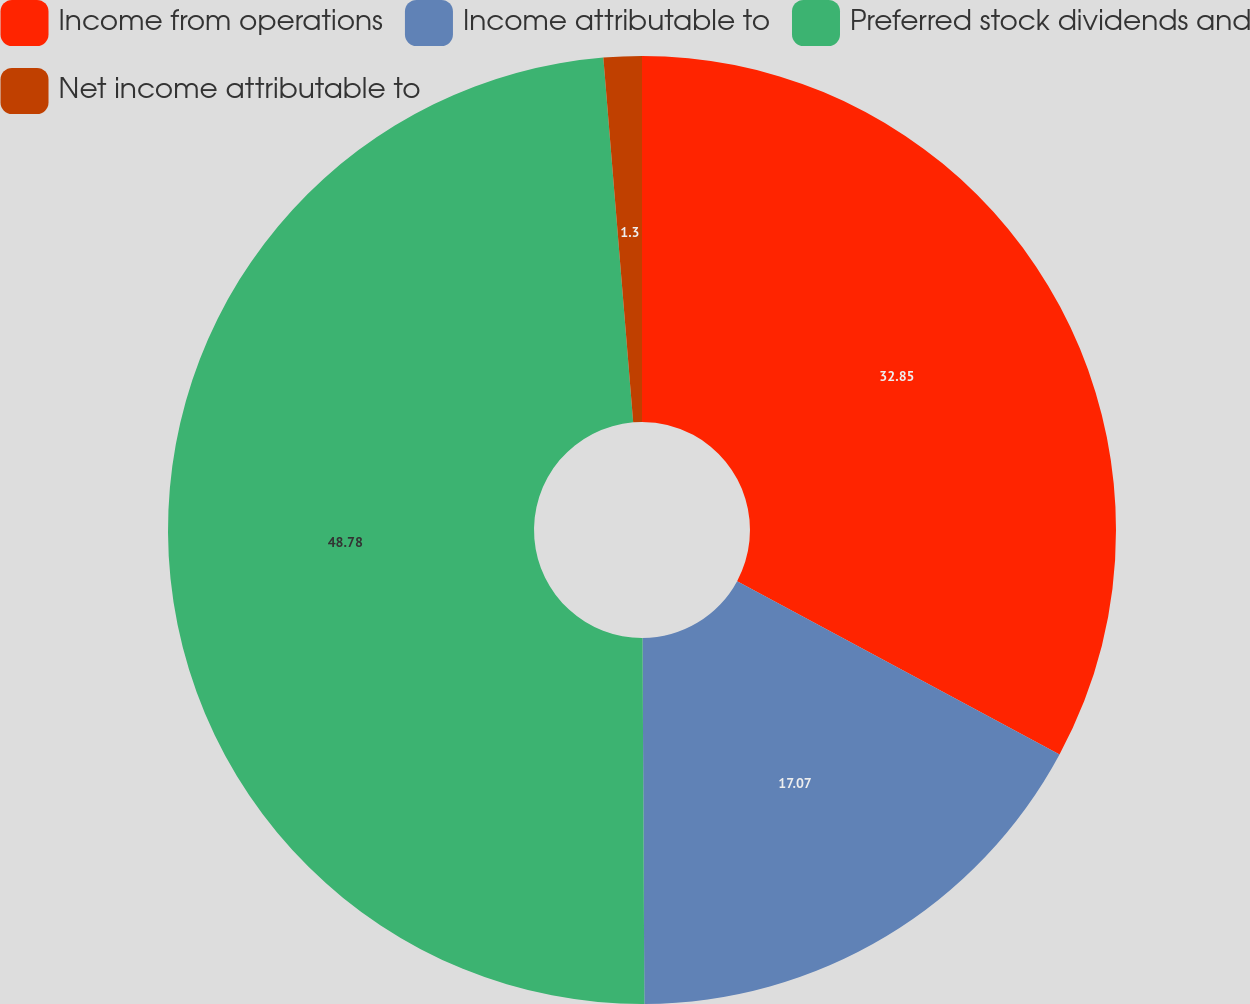Convert chart to OTSL. <chart><loc_0><loc_0><loc_500><loc_500><pie_chart><fcel>Income from operations<fcel>Income attributable to<fcel>Preferred stock dividends and<fcel>Net income attributable to<nl><fcel>32.85%<fcel>17.07%<fcel>48.78%<fcel>1.3%<nl></chart> 